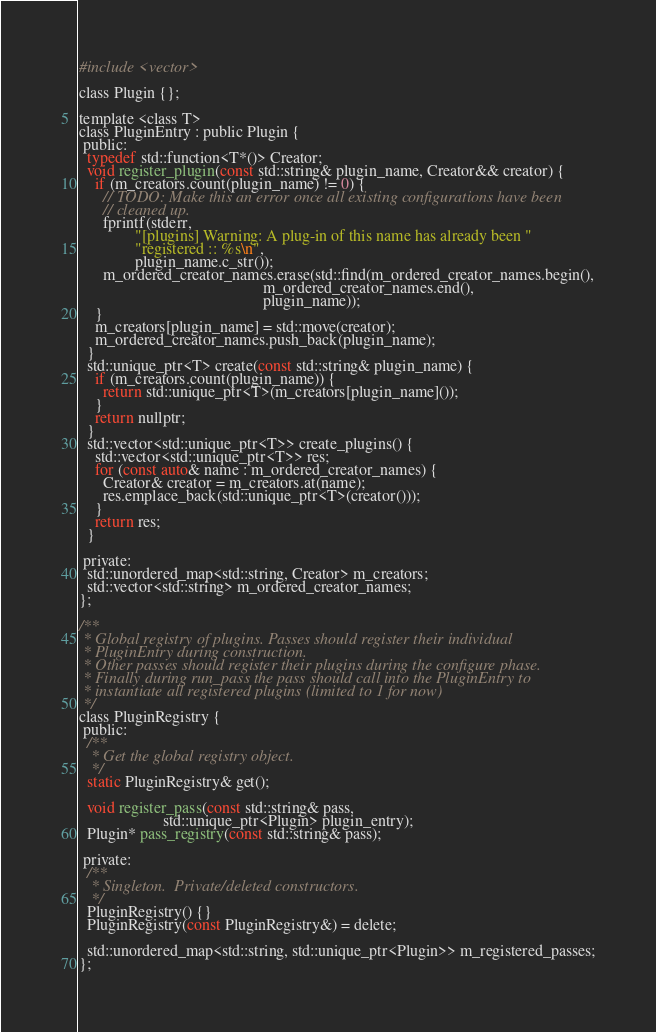Convert code to text. <code><loc_0><loc_0><loc_500><loc_500><_C_>#include <vector>

class Plugin {};

template <class T>
class PluginEntry : public Plugin {
 public:
  typedef std::function<T*()> Creator;
  void register_plugin(const std::string& plugin_name, Creator&& creator) {
    if (m_creators.count(plugin_name) != 0) {
      // TODO: Make this an error once all existing configurations have been
      // cleaned up.
      fprintf(stderr,
              "[plugins] Warning: A plug-in of this name has already been "
              "registered :: %s\n",
              plugin_name.c_str());
      m_ordered_creator_names.erase(std::find(m_ordered_creator_names.begin(),
                                              m_ordered_creator_names.end(),
                                              plugin_name));
    }
    m_creators[plugin_name] = std::move(creator);
    m_ordered_creator_names.push_back(plugin_name);
  }
  std::unique_ptr<T> create(const std::string& plugin_name) {
    if (m_creators.count(plugin_name)) {
      return std::unique_ptr<T>(m_creators[plugin_name]());
    }
    return nullptr;
  }
  std::vector<std::unique_ptr<T>> create_plugins() {
    std::vector<std::unique_ptr<T>> res;
    for (const auto& name : m_ordered_creator_names) {
      Creator& creator = m_creators.at(name);
      res.emplace_back(std::unique_ptr<T>(creator()));
    }
    return res;
  }

 private:
  std::unordered_map<std::string, Creator> m_creators;
  std::vector<std::string> m_ordered_creator_names;
};

/**
 * Global registry of plugins. Passes should register their individual
 * PluginEntry during construction.
 * Other passes should register their plugins during the configure phase.
 * Finally during run_pass the pass should call into the PluginEntry to
 * instantiate all registered plugins (limited to 1 for now)
 */
class PluginRegistry {
 public:
  /**
   * Get the global registry object.
   */
  static PluginRegistry& get();

  void register_pass(const std::string& pass,
                     std::unique_ptr<Plugin> plugin_entry);
  Plugin* pass_registry(const std::string& pass);

 private:
  /**
   * Singleton.  Private/deleted constructors.
   */
  PluginRegistry() {}
  PluginRegistry(const PluginRegistry&) = delete;

  std::unordered_map<std::string, std::unique_ptr<Plugin>> m_registered_passes;
};
</code> 